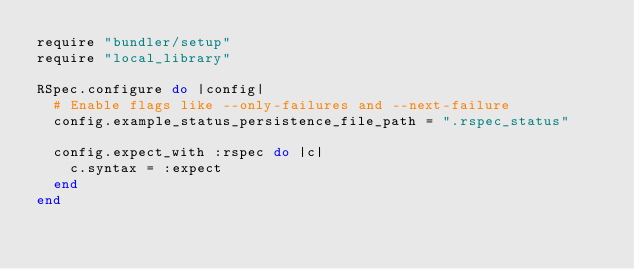Convert code to text. <code><loc_0><loc_0><loc_500><loc_500><_Ruby_>require "bundler/setup"
require "local_library"

RSpec.configure do |config|
  # Enable flags like --only-failures and --next-failure
  config.example_status_persistence_file_path = ".rspec_status"

  config.expect_with :rspec do |c|
    c.syntax = :expect
  end
end
</code> 